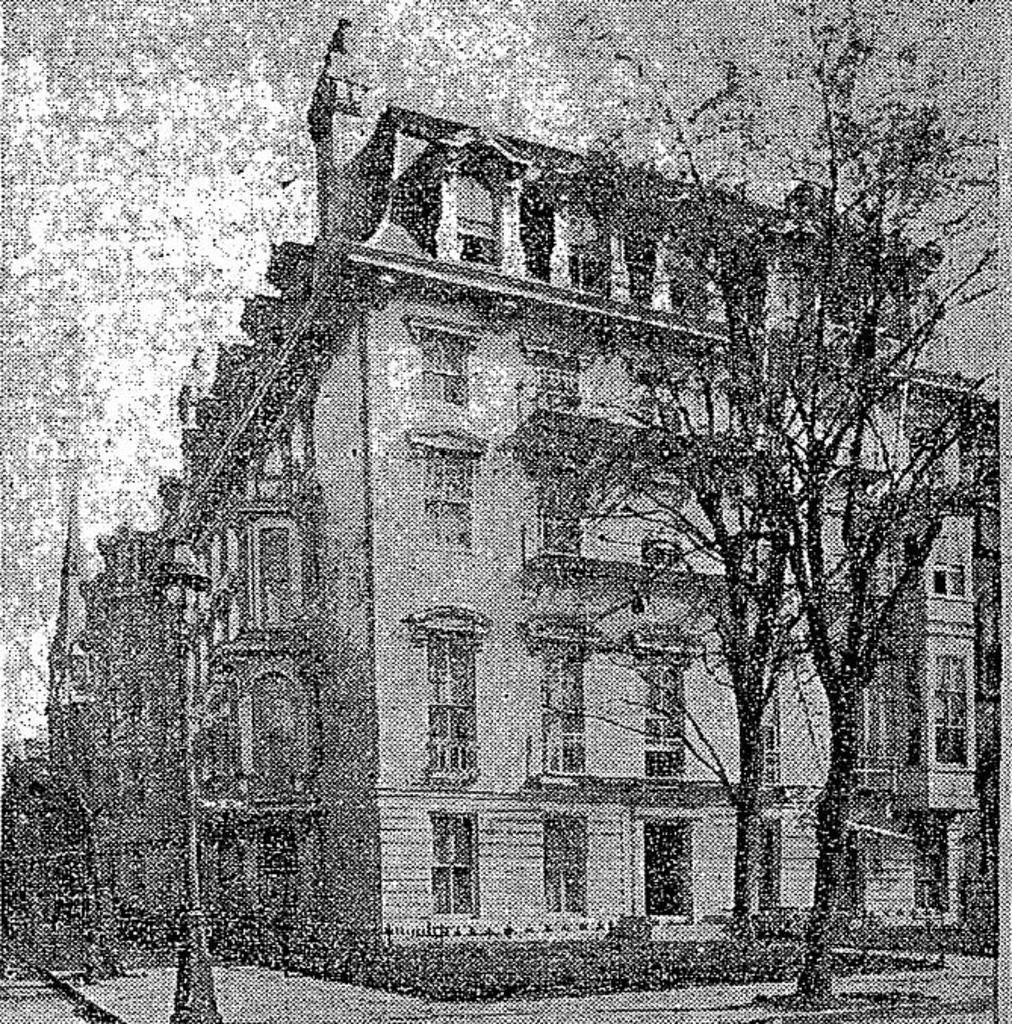What type of structure is present in the image? There is a building in the image. What other natural elements can be seen in the image? There are trees in the image. What is the purpose of the object with a light on top? There is a light pole in the image, which is used to provide illumination. What can be seen above the building and trees? The sky is visible in the image. How is the image presented in terms of color? The image is in black and white. How does the building care for the trees in the image? The image does not depict any interaction between the building and the trees, so it is not possible to determine how the building cares for the trees. 